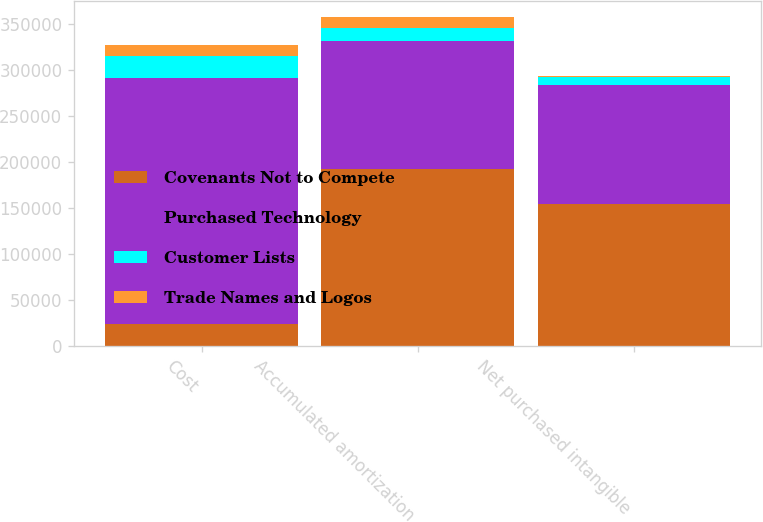Convert chart. <chart><loc_0><loc_0><loc_500><loc_500><stacked_bar_chart><ecel><fcel>Cost<fcel>Accumulated amortization<fcel>Net purchased intangible<nl><fcel>Covenants Not to Compete<fcel>23696<fcel>192367<fcel>154058<nl><fcel>Purchased Technology<fcel>267693<fcel>138566<fcel>129127<nl><fcel>Customer Lists<fcel>23696<fcel>14580<fcel>9116<nl><fcel>Trade Names and Logos<fcel>12313<fcel>11730<fcel>583<nl></chart> 